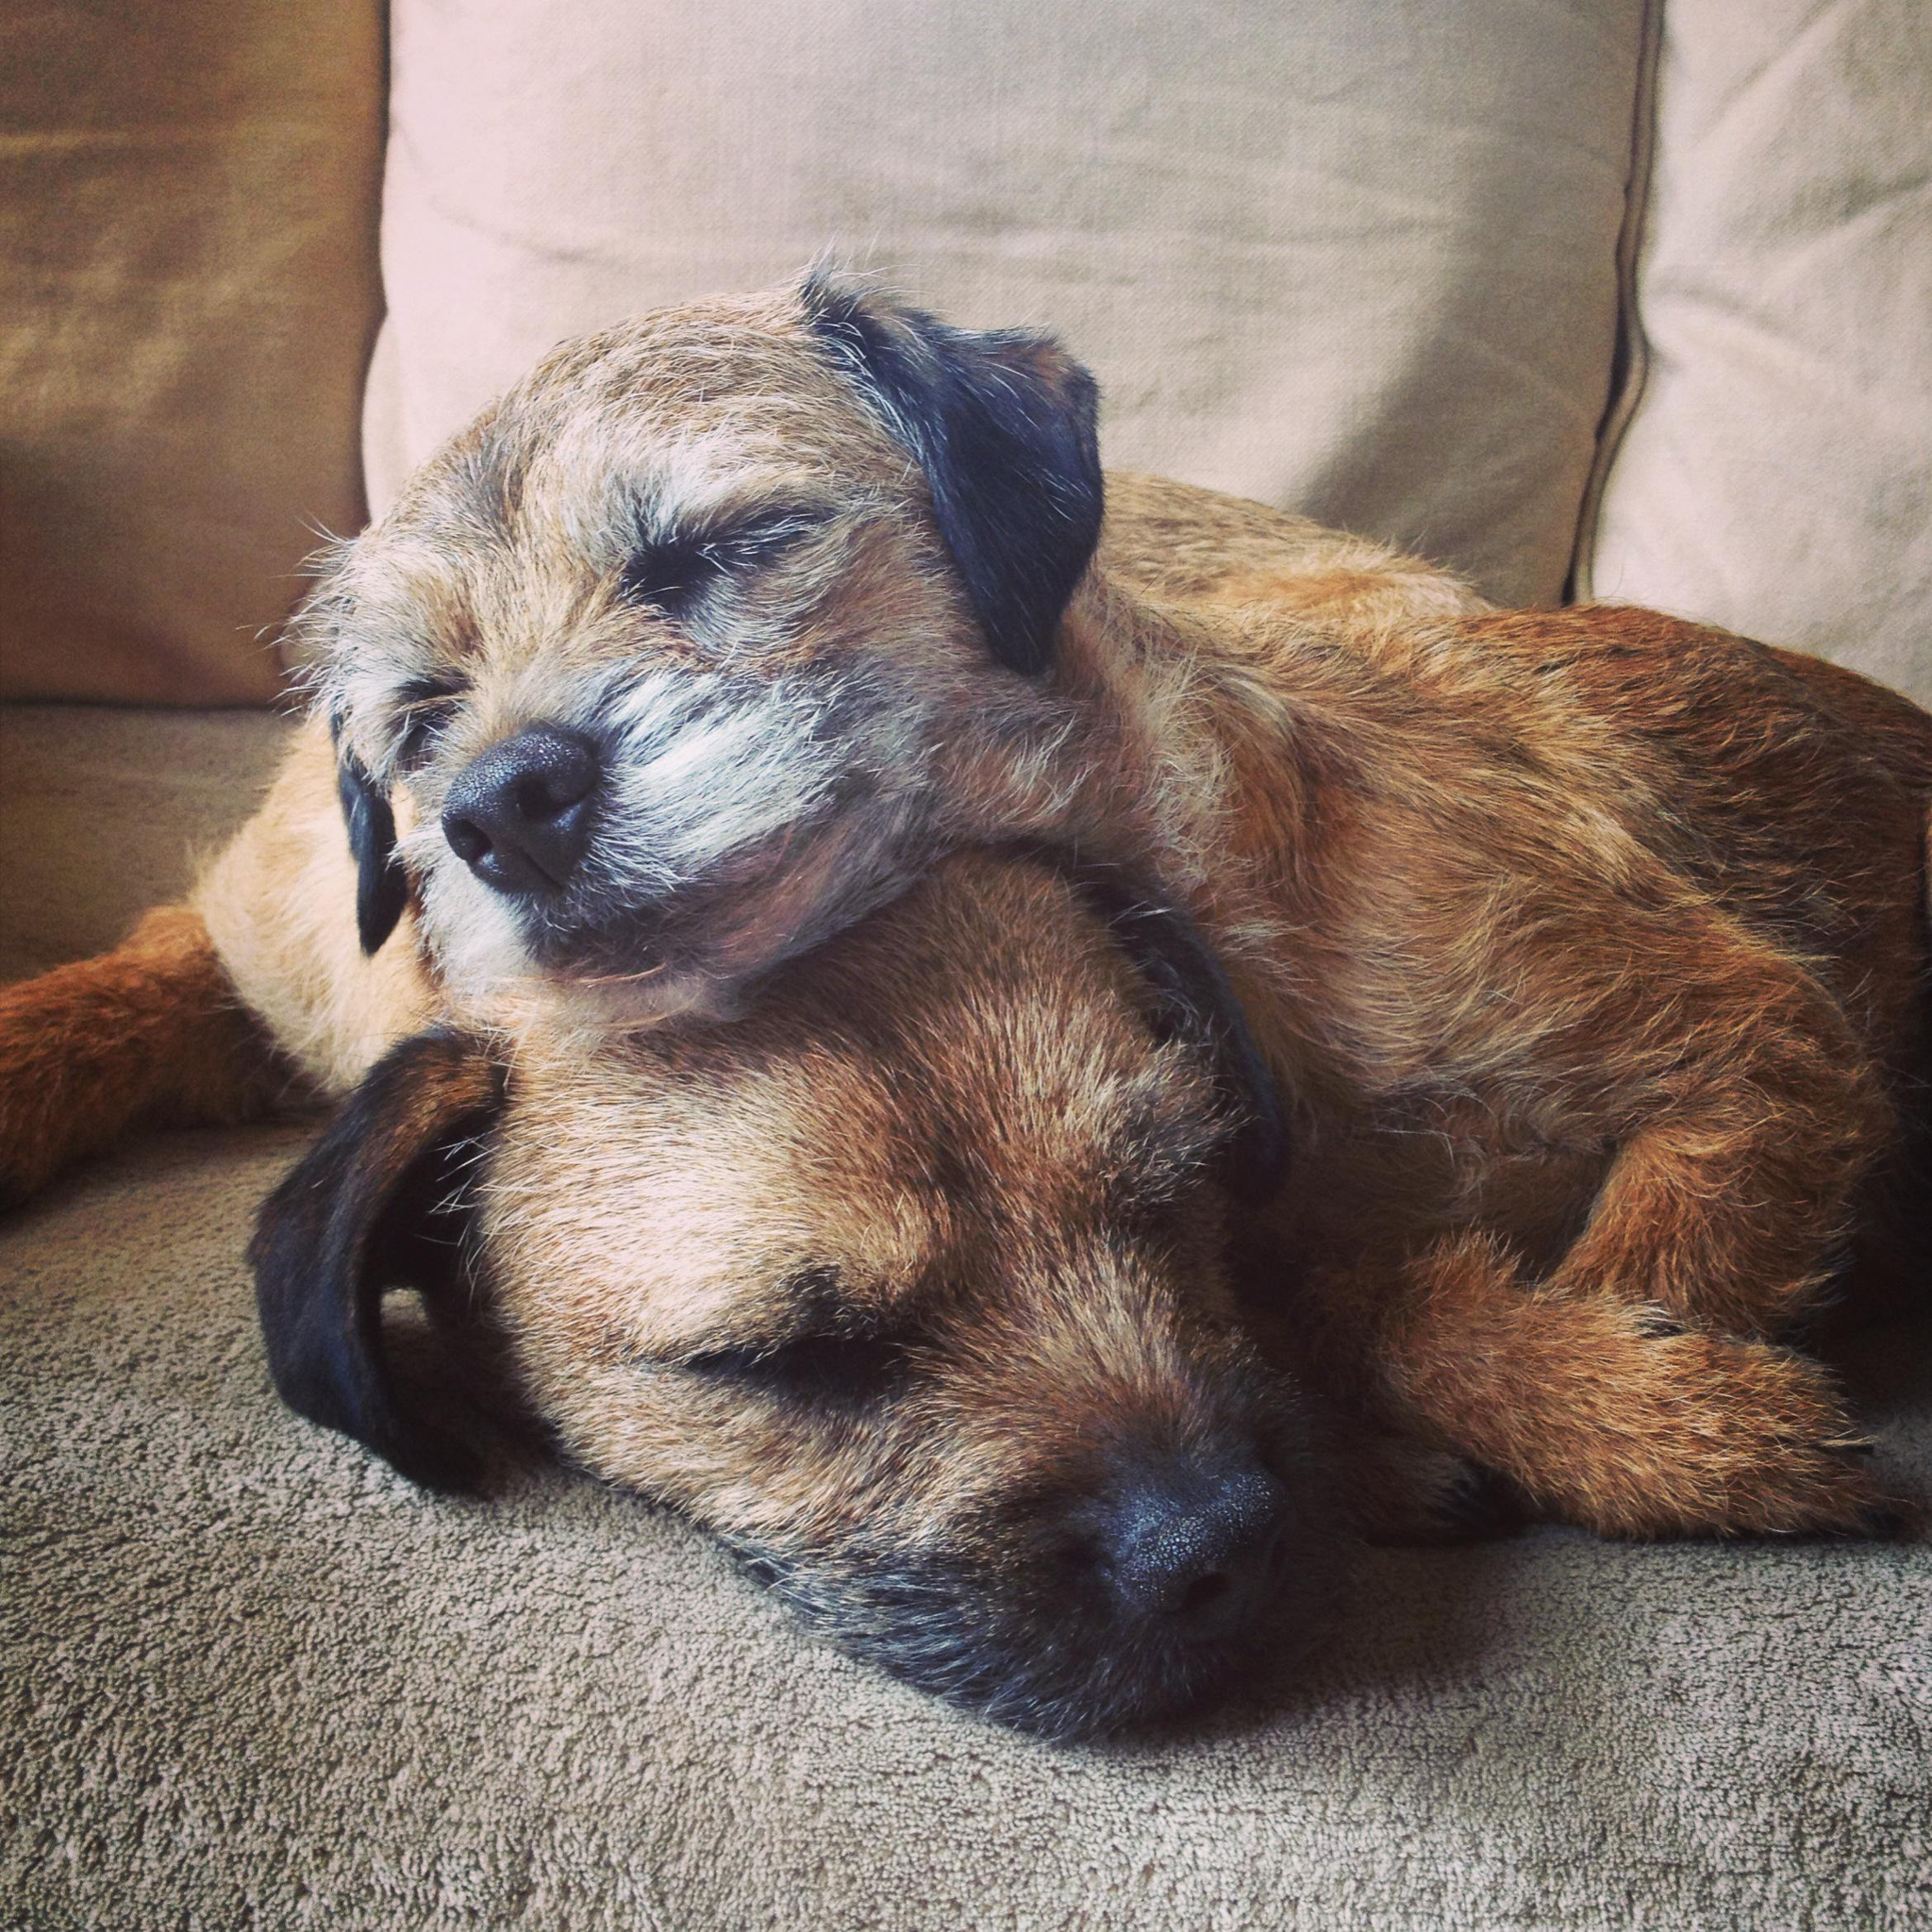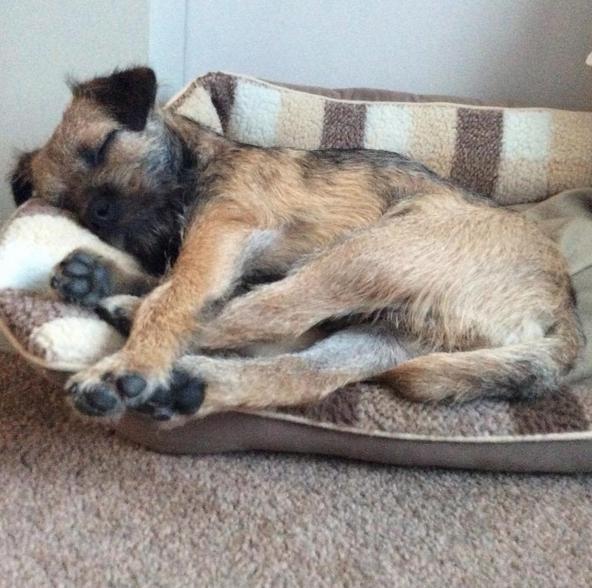The first image is the image on the left, the second image is the image on the right. For the images shown, is this caption "One image shows two dogs snoozing together." true? Answer yes or no. Yes. The first image is the image on the left, the second image is the image on the right. For the images displayed, is the sentence "There are three dogs sleeping" factually correct? Answer yes or no. Yes. 